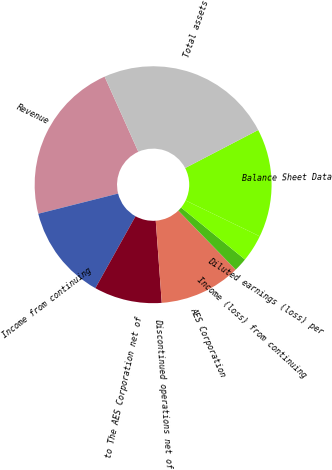Convert chart. <chart><loc_0><loc_0><loc_500><loc_500><pie_chart><fcel>Revenue<fcel>Income from continuing<fcel>to The AES Corporation net of<fcel>Discontinued operations net of<fcel>AES Corporation<fcel>Income (loss) from continuing<fcel>Diluted earnings (loss) per<fcel>Balance Sheet Data<fcel>Total assets<nl><fcel>22.22%<fcel>12.96%<fcel>9.26%<fcel>0.0%<fcel>11.11%<fcel>1.85%<fcel>3.7%<fcel>14.81%<fcel>24.07%<nl></chart> 